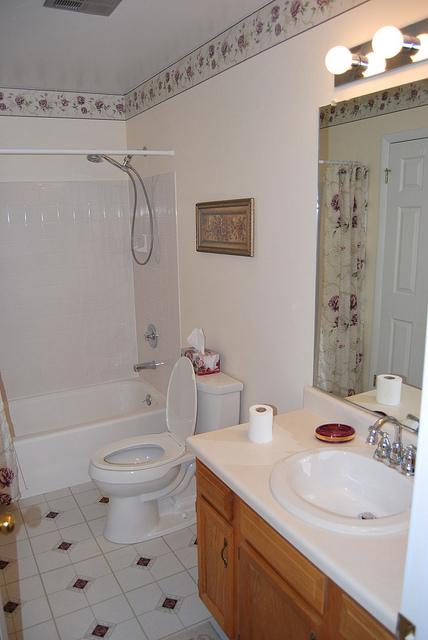How many diamond shapes are here?
Write a very short answer. 10. Where is the toilet paper?
Quick response, please. Counter. What room is this?
Write a very short answer. Bathroom. Is this a bathroom?
Answer briefly. Yes. What is in the top right corner of the picture?
Quick response, please. Lights. What is decorating the walls?
Be succinct. Picture. What material is the sink made of?
Give a very brief answer. Porcelain. What color is the countertop?
Short answer required. White. Is this a washing machine?
Write a very short answer. No. What is this room?
Answer briefly. Bathroom. Is there an apple computer in this room?
Keep it brief. No. 